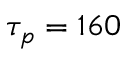<formula> <loc_0><loc_0><loc_500><loc_500>\tau _ { p } = 1 6 0</formula> 